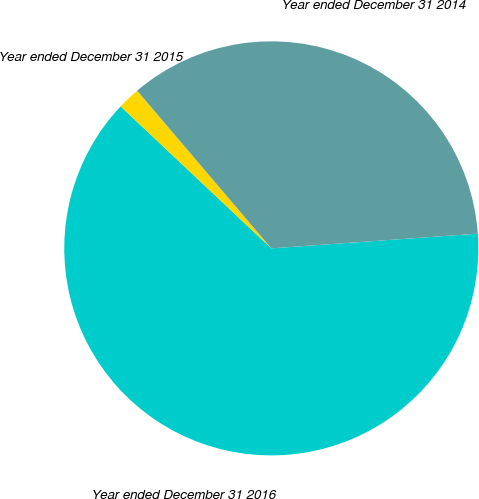Convert chart to OTSL. <chart><loc_0><loc_0><loc_500><loc_500><pie_chart><fcel>Year ended December 31 2016<fcel>Year ended December 31 2015<fcel>Year ended December 31 2014<nl><fcel>63.16%<fcel>1.75%<fcel>35.09%<nl></chart> 